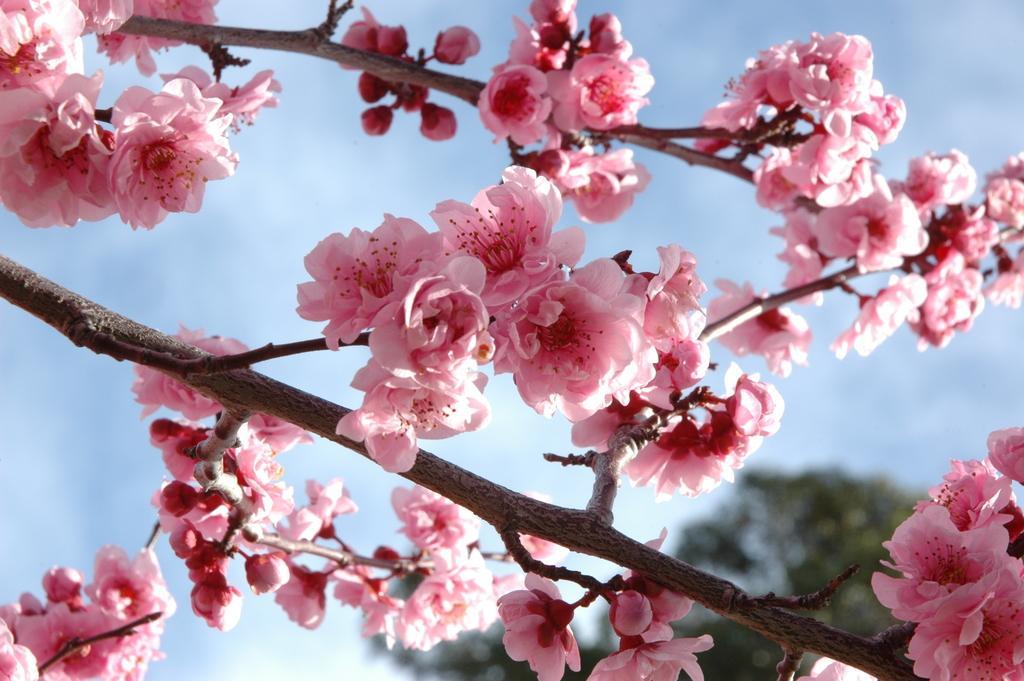Describe this image in one or two sentences. Here we can see flowers and branches. In the background we can see a tree and clouds in the sky. 